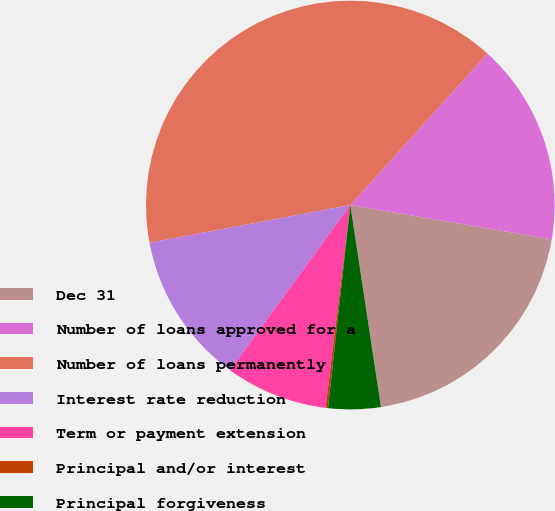Convert chart. <chart><loc_0><loc_0><loc_500><loc_500><pie_chart><fcel>Dec 31<fcel>Number of loans approved for a<fcel>Number of loans permanently<fcel>Interest rate reduction<fcel>Term or payment extension<fcel>Principal and/or interest<fcel>Principal forgiveness<nl><fcel>19.92%<fcel>15.98%<fcel>39.66%<fcel>12.03%<fcel>8.08%<fcel>0.19%<fcel>4.14%<nl></chart> 